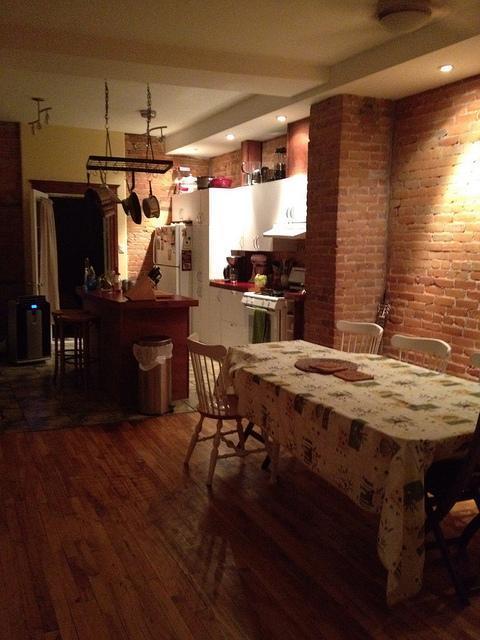How many chairs are in the photo?
Give a very brief answer. 2. How many people are on the boats?
Give a very brief answer. 0. 